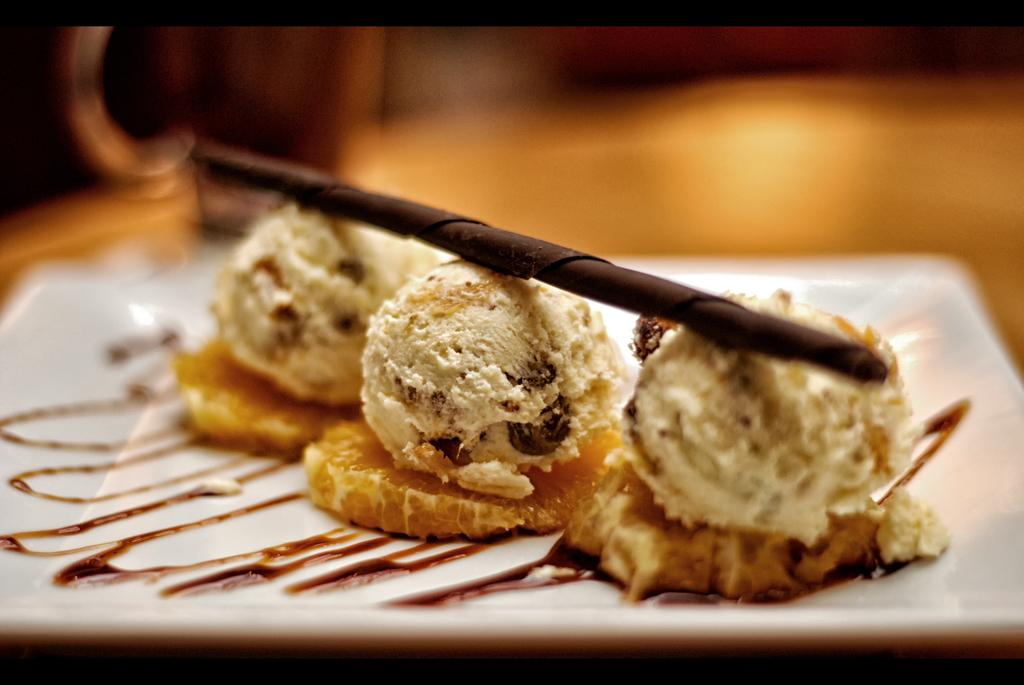What is on the plate that is visible in the image? There is food on a white plate in the image. Can you describe the quality of the image? The image is blurry at the back. What direction does the cart turn in the image? There is no cart present in the image. How does the food blow away in the image? The food does not blow away in the image; it is stationary on the plate. 